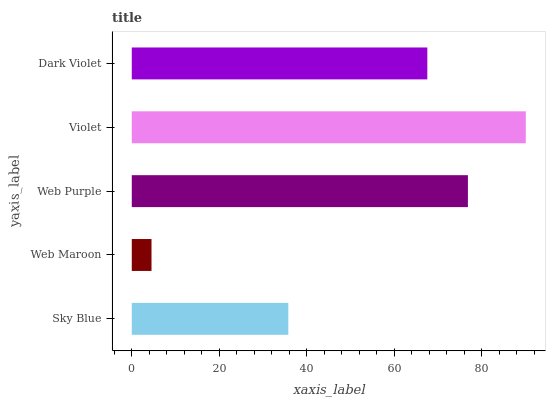Is Web Maroon the minimum?
Answer yes or no. Yes. Is Violet the maximum?
Answer yes or no. Yes. Is Web Purple the minimum?
Answer yes or no. No. Is Web Purple the maximum?
Answer yes or no. No. Is Web Purple greater than Web Maroon?
Answer yes or no. Yes. Is Web Maroon less than Web Purple?
Answer yes or no. Yes. Is Web Maroon greater than Web Purple?
Answer yes or no. No. Is Web Purple less than Web Maroon?
Answer yes or no. No. Is Dark Violet the high median?
Answer yes or no. Yes. Is Dark Violet the low median?
Answer yes or no. Yes. Is Sky Blue the high median?
Answer yes or no. No. Is Violet the low median?
Answer yes or no. No. 